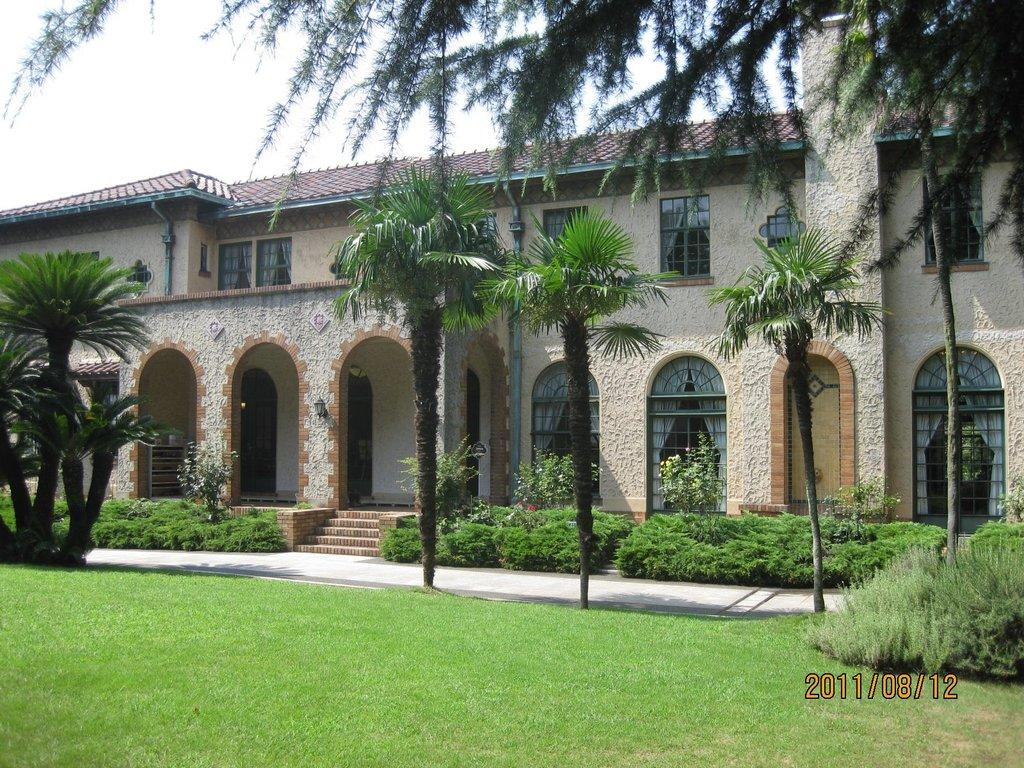What type of vegetation is present in the image? There is grass, plants, and trees in the image. What type of structure is visible in the image? There is a building in the image. What can be seen on the walls of the building? There are pipes on the walls in the image. Is there any indication of when the image was taken? Yes, there is a timestamp at the right bottom of the image. What type of appliance is being used by the horses in the image? There are no horses or appliances present in the image. 